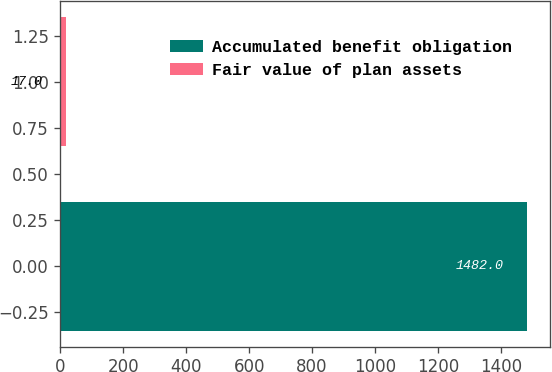Convert chart to OTSL. <chart><loc_0><loc_0><loc_500><loc_500><bar_chart><fcel>Accumulated benefit obligation<fcel>Fair value of plan assets<nl><fcel>1482<fcel>17<nl></chart> 